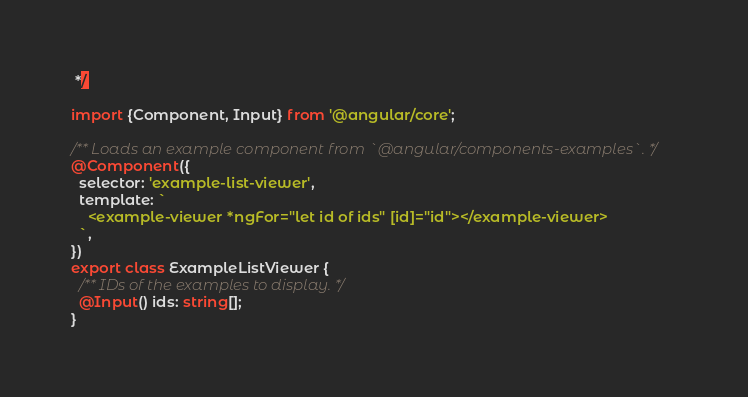Convert code to text. <code><loc_0><loc_0><loc_500><loc_500><_TypeScript_> */

import {Component, Input} from '@angular/core';

/** Loads an example component from `@angular/components-examples`. */
@Component({
  selector: 'example-list-viewer',
  template: `
    <example-viewer *ngFor="let id of ids" [id]="id"></example-viewer>
  `,
})
export class ExampleListViewer {
  /** IDs of the examples to display. */
  @Input() ids: string[];
}
</code> 